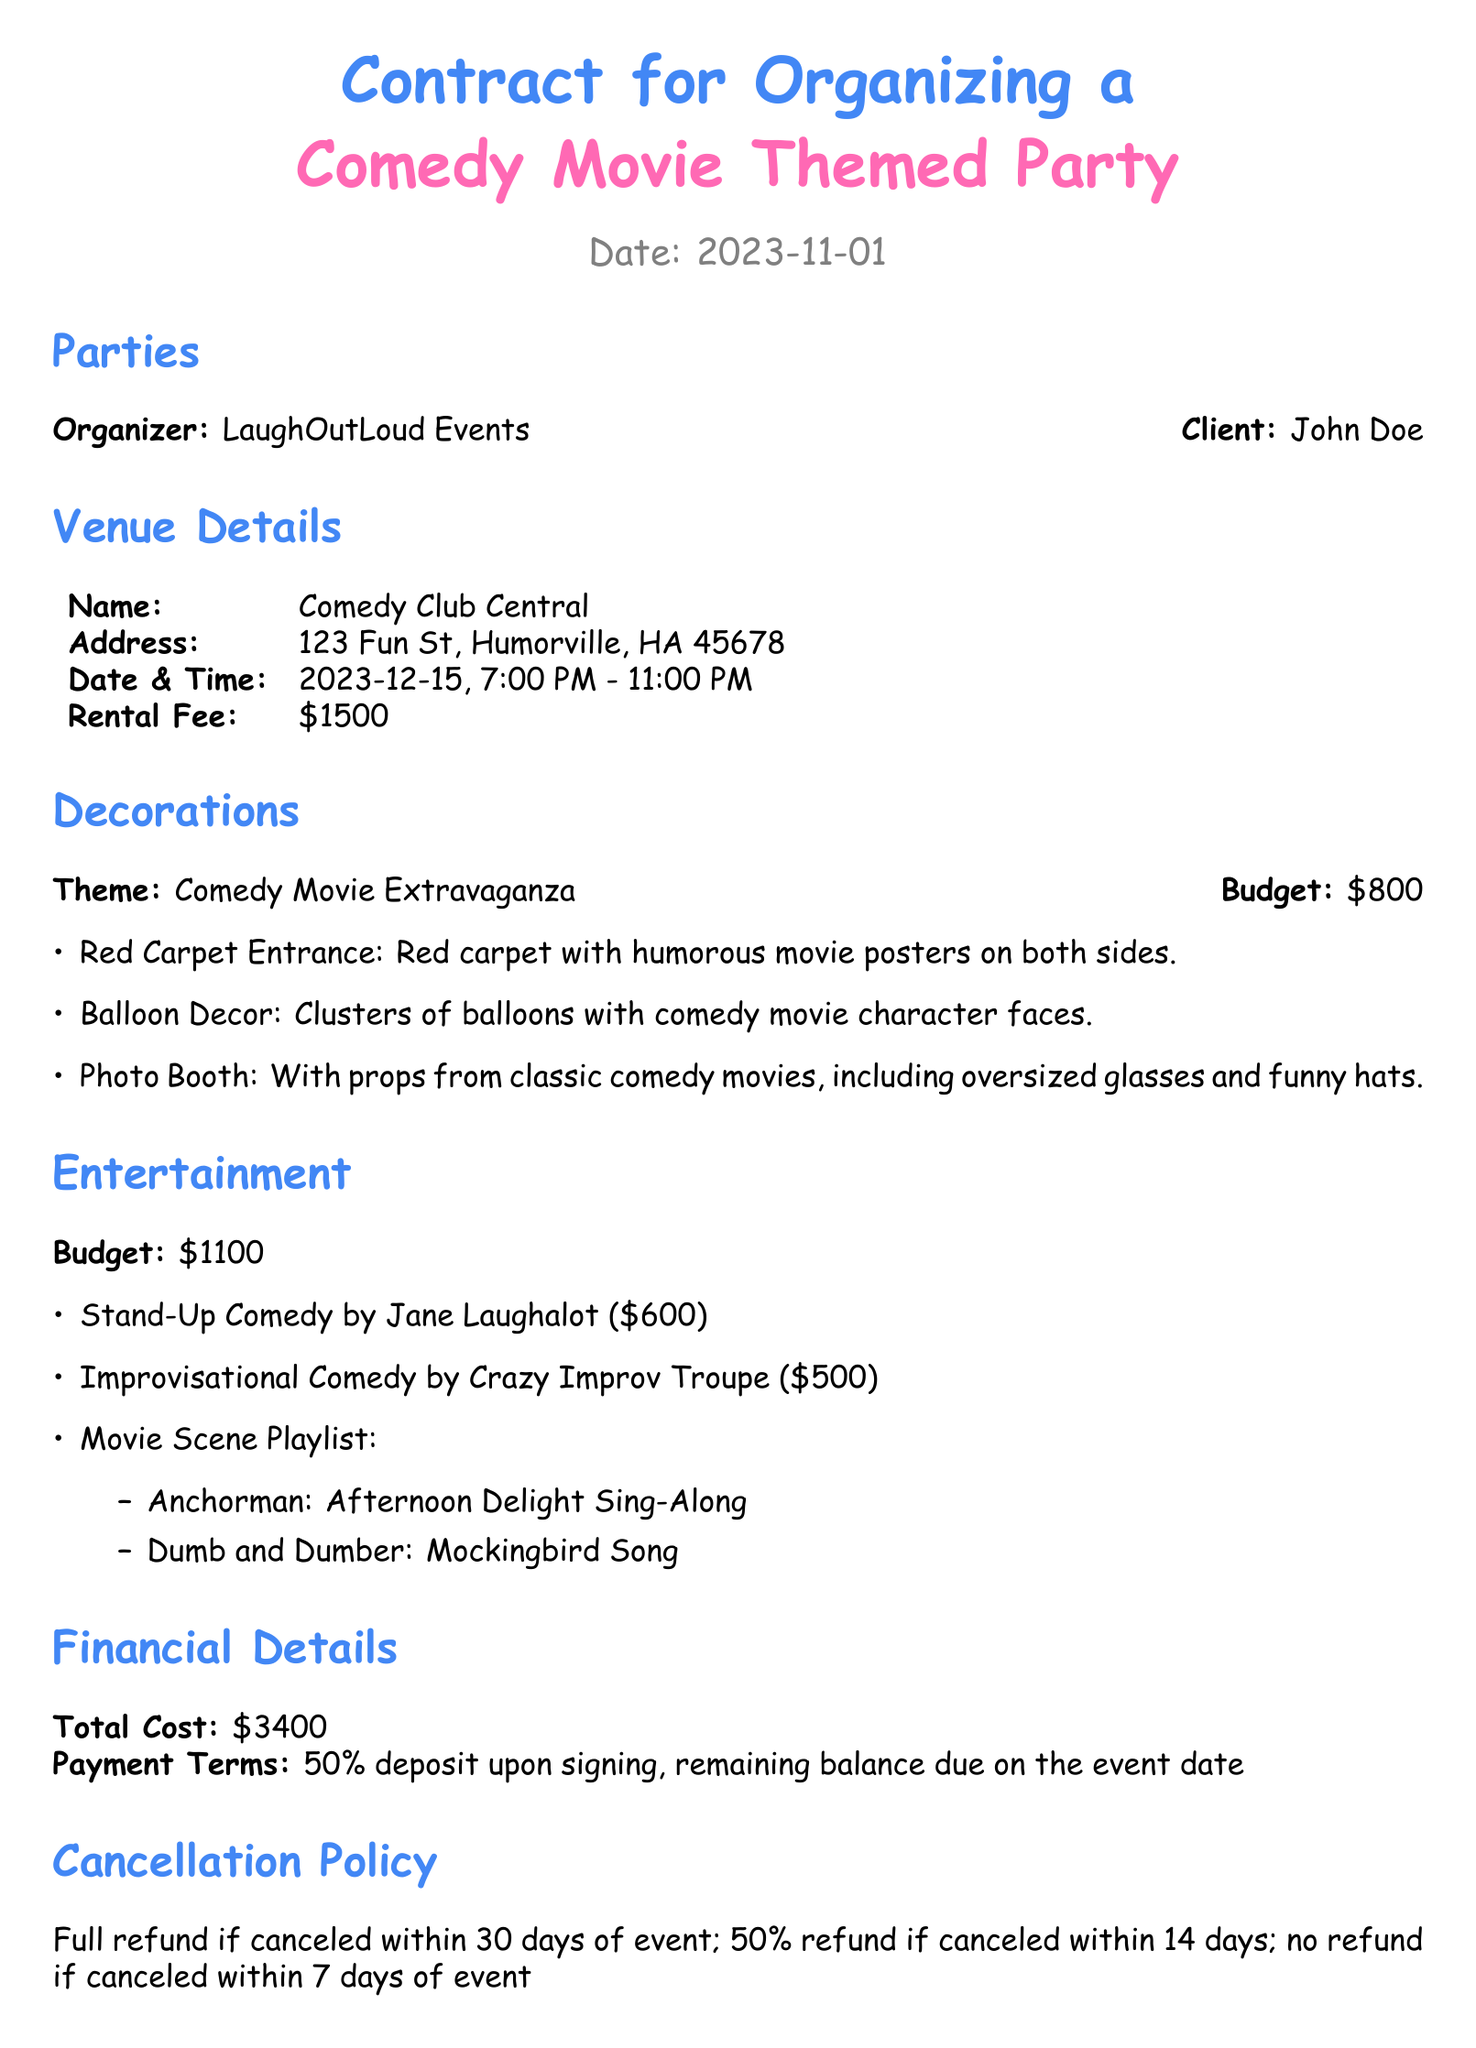What is the name of the organizer? The name of the organizer is listed in the document under the section "Parties."
Answer: LaughOutLoud Events What is the rental fee for the venue? The rental fee is specified in the "Venue Details" section of the document.
Answer: $1500 What is the date and time of the event? The date and time are provided in the "Venue Details" section.
Answer: 2023-12-15, 7:00 PM - 11:00 PM What is the total cost of the event? The total cost is listed in the "Financial Details" section.
Answer: $3400 How much is the deposit required upon signing? The payment terms indicate the deposit amount that needs to be paid initially.
Answer: 50% What is the theme of the decorations? The theme is mentioned in the "Decorations" section of the document.
Answer: Comedy Movie Extravaganza Who is performing stand-up comedy at the event? The entertainment section lists the performers for the event.
Answer: Jane Laughalot What is the cancellation policy for the event? The cancellation policy outlines the refunds based on the cancellation notice period.
Answer: Full refund if canceled within 30 days of event What is included in the movie scene playlist? The entertainment section includes specific movie scene songs.
Answer: Anchorman: Afternoon Delight Sing-Along, Dumb and Dumber: Mockingbird Song What is the budget allocated for decorations? The budget for decorations is specified in the "Decorations" section.
Answer: $800 